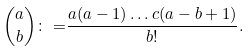<formula> <loc_0><loc_0><loc_500><loc_500>\binom { a } { b } \colon = & \frac { a ( a - 1 ) \dots c ( a - b + 1 ) } { b ! } .</formula> 